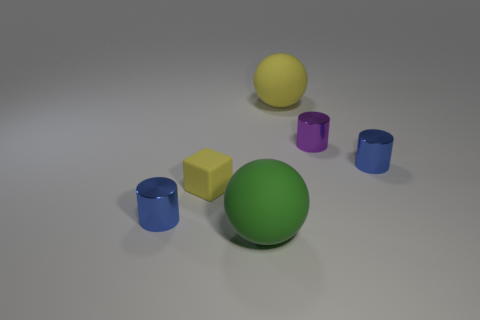What does the lighting in the scene suggest about the setting? The lighting in the scene is soft and diffused, with gentle shadows cast under each object, suggesting an indoor setting with natural light possibly coming from a nearby window or soft artificial lighting. There's no harsh light or stark contrast, which gives the scene a calm and controlled atmosphere, likely designed to focus on the objects without environmental distractions. 